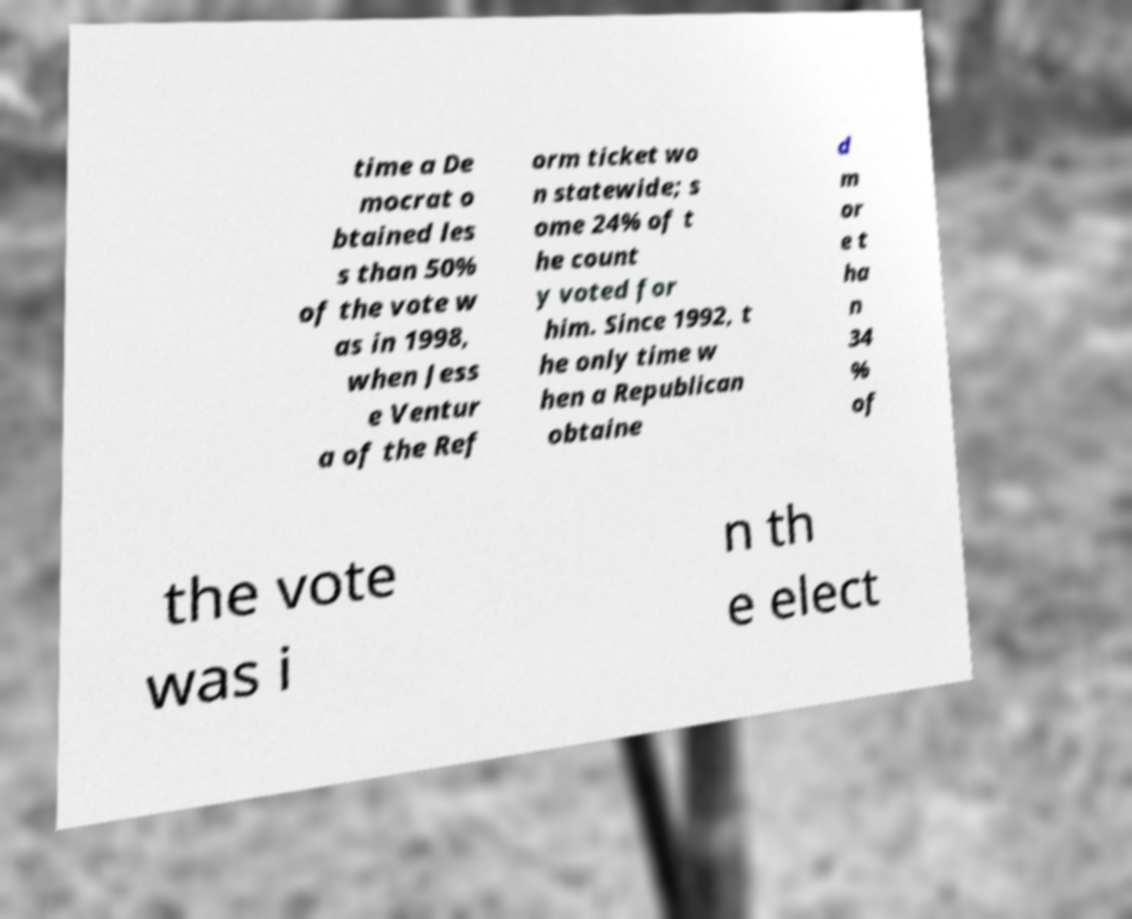Can you accurately transcribe the text from the provided image for me? time a De mocrat o btained les s than 50% of the vote w as in 1998, when Jess e Ventur a of the Ref orm ticket wo n statewide; s ome 24% of t he count y voted for him. Since 1992, t he only time w hen a Republican obtaine d m or e t ha n 34 % of the vote was i n th e elect 